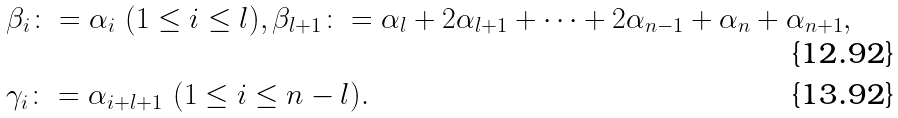<formula> <loc_0><loc_0><loc_500><loc_500>& \beta _ { i } \colon = \alpha _ { i } \ ( 1 \leq i \leq l ) , \beta _ { l + 1 } \colon = \alpha _ { l } + 2 \alpha _ { l + 1 } + \cdots + 2 \alpha _ { n - 1 } + \alpha _ { n } + \alpha _ { n + 1 } , \\ & \gamma _ { i } \colon = \alpha _ { i + l + 1 } \ ( 1 \leq i \leq n - l ) .</formula> 